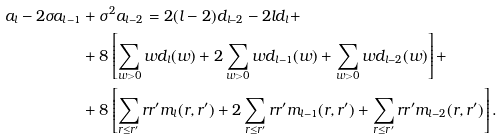<formula> <loc_0><loc_0><loc_500><loc_500>a _ { l } - 2 \sigma a _ { l - 1 } & + \sigma ^ { 2 } a _ { l - 2 } = 2 ( l - 2 ) d _ { l - 2 } - 2 l d _ { l } + \\ & + 8 \left [ \sum _ { w > 0 } w d _ { l } ( w ) + 2 \sum _ { w > 0 } w d _ { l - 1 } ( w ) + \sum _ { w > 0 } w d _ { l - 2 } ( w ) \right ] + \\ & + 8 \left [ \sum _ { r \leq r ^ { \prime } } r r ^ { \prime } m _ { l } ( r , r ^ { \prime } ) + 2 \sum _ { r \leq r ^ { \prime } } r r ^ { \prime } m _ { l - 1 } ( r , r ^ { \prime } ) + \sum _ { r \leq r ^ { \prime } } r r ^ { \prime } m _ { l - 2 } ( r , r ^ { \prime } ) \right ] .</formula> 